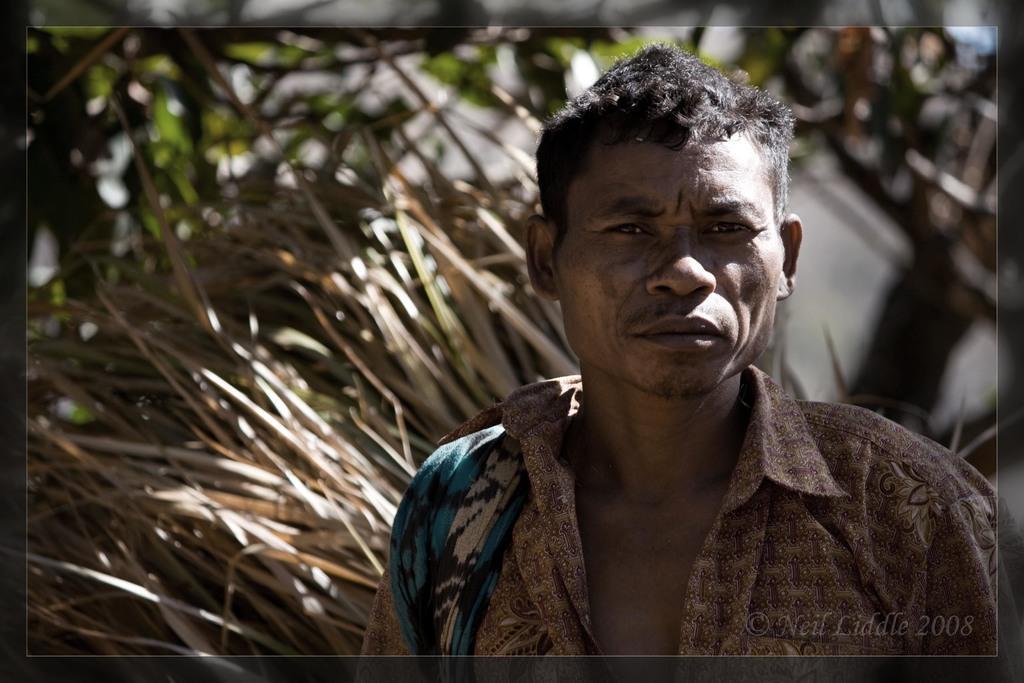How would you summarize this image in a sentence or two? On the right side of the image we can see a man, in the bottom right hand corner we can see some text. 